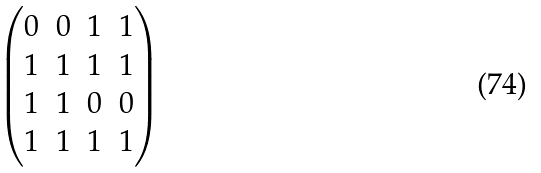Convert formula to latex. <formula><loc_0><loc_0><loc_500><loc_500>\begin{pmatrix} 0 & 0 & 1 & 1 \\ 1 & 1 & 1 & 1 \\ 1 & 1 & 0 & 0 \\ 1 & 1 & 1 & 1 \end{pmatrix}</formula> 